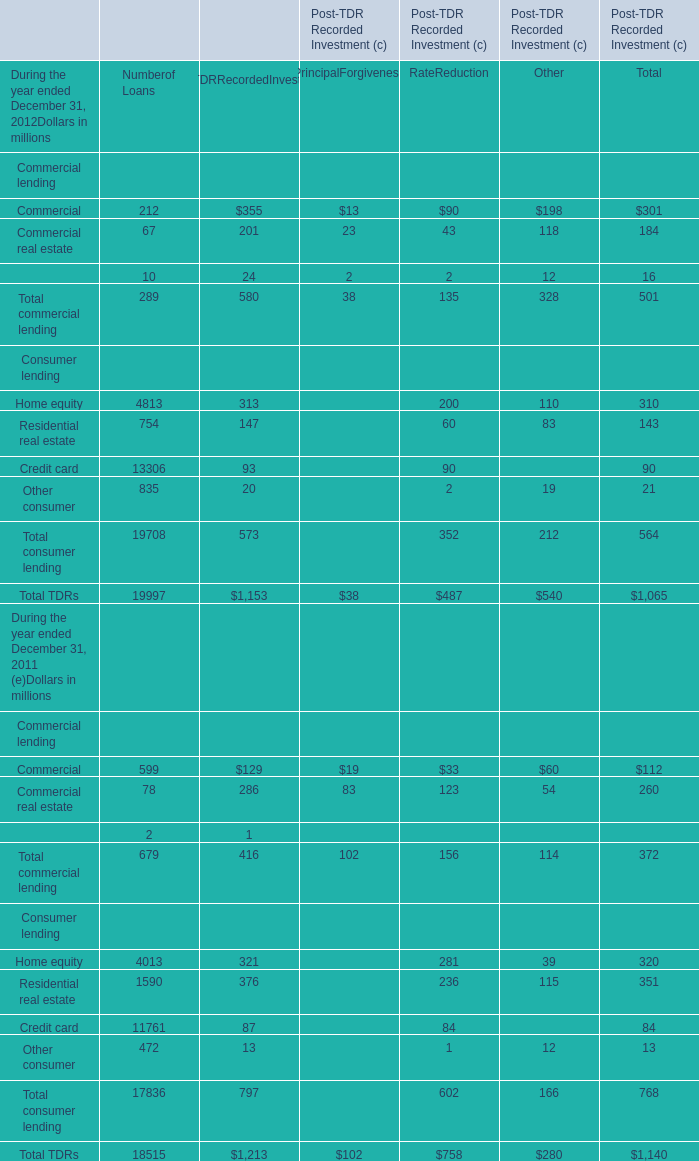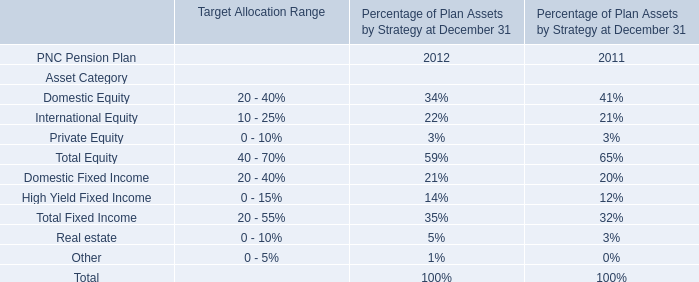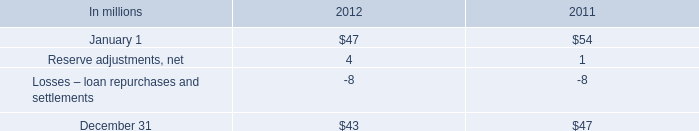what was the average , in millions , reserve for losses in 2011 and 2012? 
Computations: ((43 + 47) / 2)
Answer: 45.0. 